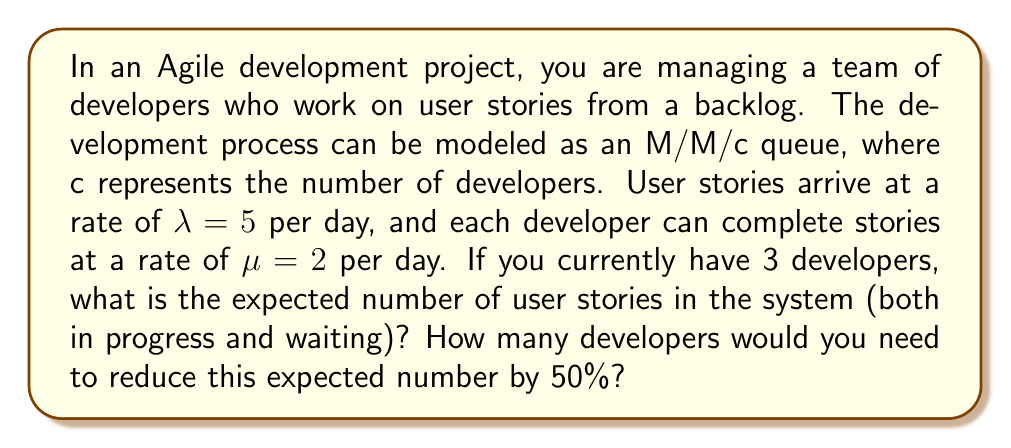Could you help me with this problem? To solve this problem, we'll use the M/M/c queueing model and follow these steps:

1. Calculate the system utilization ρ:
   $$\rho = \frac{\lambda}{c\mu} = \frac{5}{3 \cdot 2} = \frac{5}{6} \approx 0.833$$

2. Calculate the probability of an empty system (P₀):
   $$P_0 = \left[\sum_{n=0}^{c-1}\frac{(c\rho)^n}{n!} + \frac{(c\rho)^c}{c!(1-\rho)}\right]^{-1}$$
   $$P_0 = \left[1 + \frac{5}{1!} + \frac{5^2}{2!} + \frac{5^3}{3!(1-\frac{5}{6})}\right]^{-1} \approx 0.0198$$

3. Calculate the expected number of user stories in the system (L):
   $$L = L_q + c\rho$$
   Where L_q is the expected number in the queue:
   $$L_q = \frac{P_0(c\rho)^c\rho}{c!(1-\rho)^2}$$
   $$L_q = \frac{0.0198 \cdot 5^3 \cdot \frac{5}{6}}{3!(1-\frac{5}{6})^2} \approx 6.9444$$
   $$L = 6.9444 + 3 \cdot \frac{5}{6} = 9.4444$$

4. To reduce L by 50%, we need to find c such that L_new = 4.7222

5. We can use trial and error or numerical methods to find that c = 5 developers gives:
   $$\rho_{new} = \frac{5}{5 \cdot 2} = 0.5$$
   $$P_0^{new} \approx 0.0351$$
   $$L_q^{new} \approx 0.2222$$
   $$L_{new} = 0.2222 + 5 \cdot 0.5 = 2.7222$$

   This is a reduction of more than 50% from the original L.
Answer: 9.4444 user stories; 5 developers 